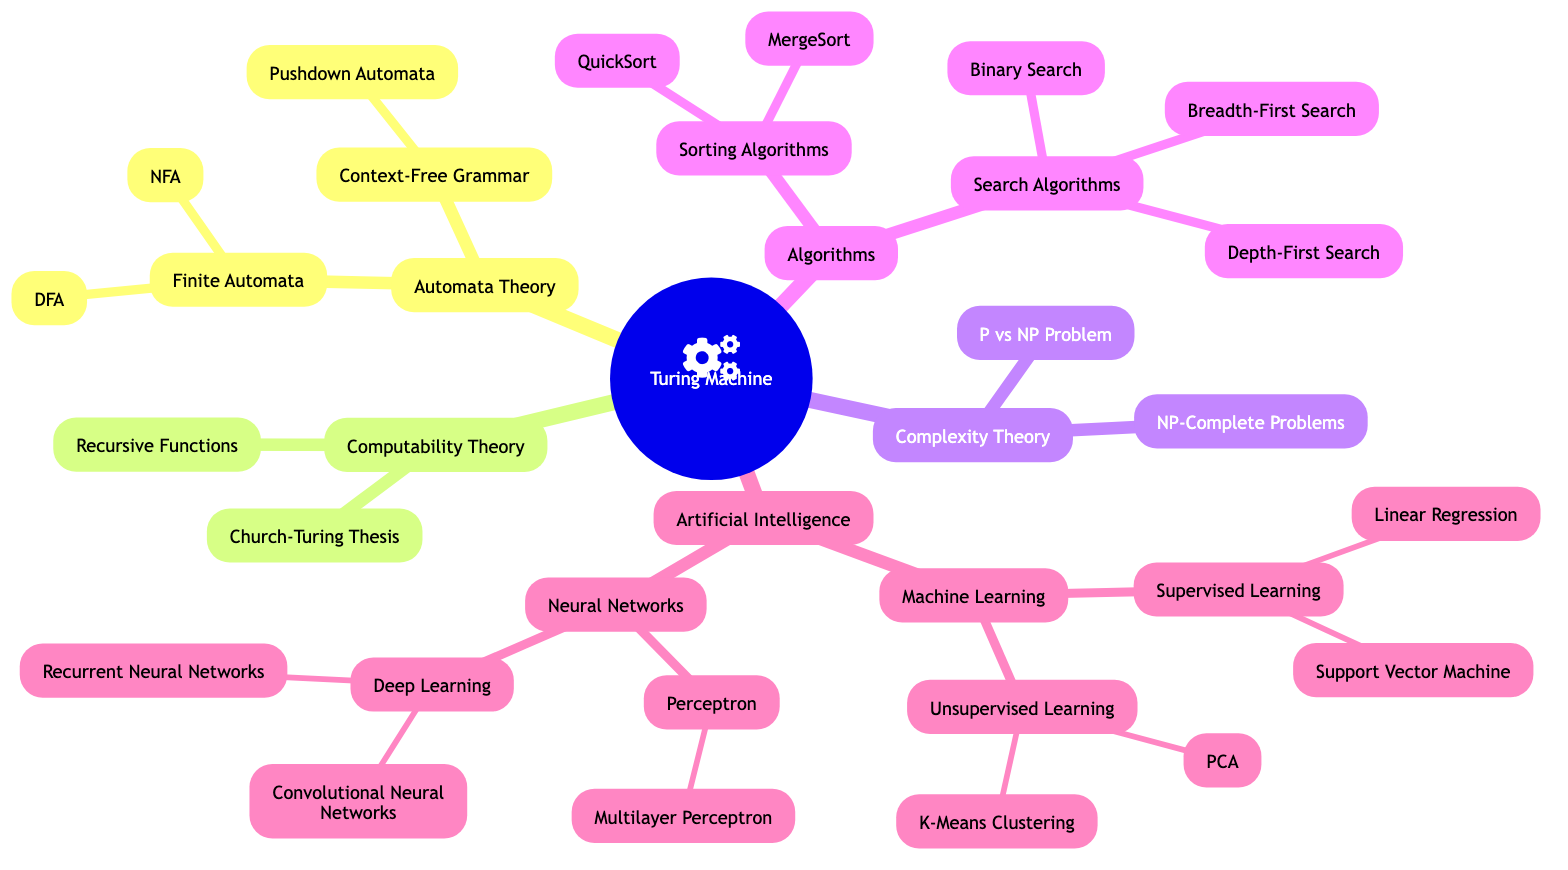What is the root of the family tree? The root of the family tree is labeled as "Turing Machine," which is the foundational node for all other concepts in this diagram.
Answer: Turing Machine How many children does the "Artificial Intelligence" node have? The "Artificial Intelligence" node has two children: "Machine Learning" and "Neural Networks," which can be counted directly from the diagram.
Answer: 2 What are the two types of finite automata? The "Finite Automata" node has two children: "DFA (Deterministic Finite Automaton)" and "NFA (Non-deterministic Finite Automaton)," clearly listed under its branch in the diagram.
Answer: DFA and NFA Which branch would you find "Church-Turing Thesis" in? "Church-Turing Thesis" is under the "Computability Theory" branch, which can be identified by following the hierarchy shown in the diagram directly to that node.
Answer: Computability Theory What type of learning includes "Support Vector Machine"? "Support Vector Machine" is categorized under the "Supervised Learning" node, which is a child of "Machine Learning." This hierarchical relationship can be traced through the diagram.
Answer: Supervised Learning Which concept is a child of "Neural Networks"? The "Perceptron" and "Deep Learning" are both children of "Neural Networks," which can be deduced from following the branches of the diagram.
Answer: Perceptron and Deep Learning What is the relationship between "Complexity Theory" and "P vs NP Problem"? "P vs NP Problem" is a child node of "Complexity Theory," showing a direct parent-child relationship in the structure of the family tree.
Answer: Parent-child How many types of search algorithms are displayed? There are three search algorithms shown as children under the "Search Algorithms" node: "Binary Search," "Depth-First Search," and "Breadth-First Search." This is evident from counting the listed nodes under "Search Algorithms."
Answer: 3 What is the most specific type of machine learning shown? The most specific type of machine learning shown is "Linear Regression," as it is a child of "Supervised Learning," which itself is a child of "Machine Learning." This specificity is traced from the hierarchy in the diagram.
Answer: Linear Regression 